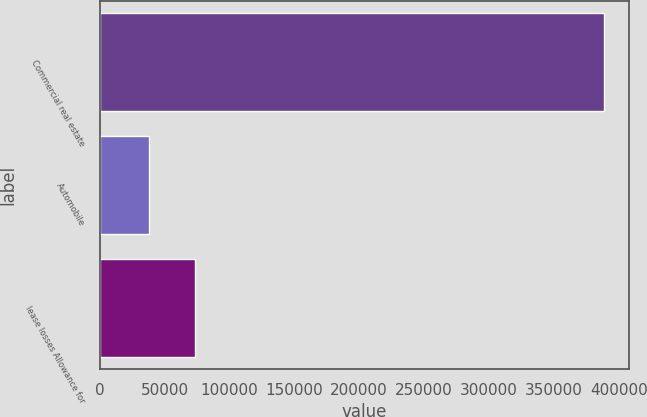<chart> <loc_0><loc_0><loc_500><loc_500><bar_chart><fcel>Commercial real estate<fcel>Automobile<fcel>lease losses Allowance for<nl><fcel>388706<fcel>38282<fcel>73324.4<nl></chart> 